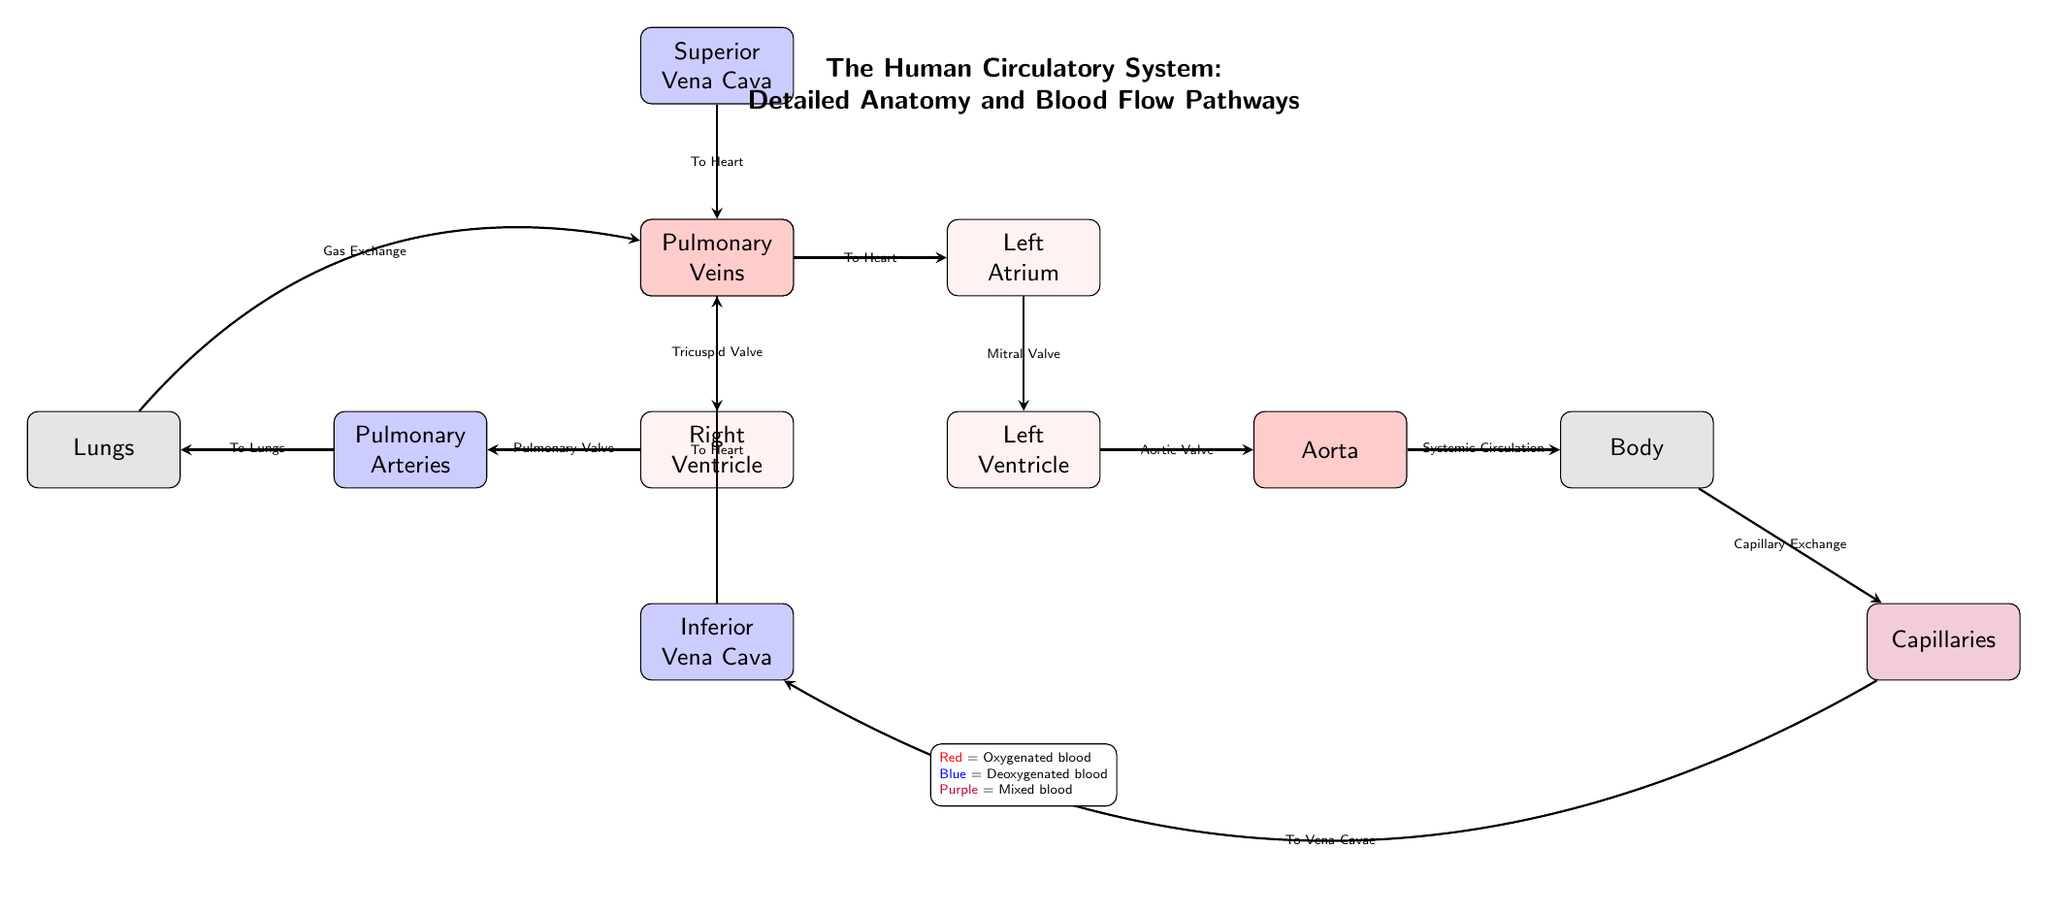What is the color representing oxygenated blood in the diagram? The diagram uses red to represent oxygenated blood, which is indicated in the legend stating that red equals oxygenated blood.
Answer: Red How many heart chambers are shown in the diagram? The diagram displays four heart chambers: the right atrium, right ventricle, left atrium, and left ventricle, which can be counted directly from the labeled nodes.
Answer: Four What valve leads from the right atrium to the right ventricle? The diagram indicates that the valve leading from the right atrium to the right ventricle is the tricuspid valve, as labeled on the corresponding edge in the diagram.
Answer: Tricuspid Valve What is the pathway taken by deoxygenated blood after it leaves the right ventricle? Deoxygenated blood exits the right ventricle through the pulmonary valve and flows into the pulmonary arteries, from where it travels to the lungs for gas exchange; this sequence is traced through the diagram.
Answer: Pulmonary Arteries Where does oxygenated blood flow after passing through the left ventricle? Once oxygenated blood passes through the left ventricle, it flows into the aorta, as indicated by the labeled connection from the left ventricle to the aorta in the diagram.
Answer: Aorta What is the final destination of blood that has completed gas exchange in the body? Blood that has undergone gas exchange in the body ends up at the capillaries, before being directed back towards the inferior vena cava, as depicted in the flow sequence of the diagram.
Answer: Capillaries Which blood vessels bring deoxygenated blood to the heart? The superior vena cava and inferior vena cava are responsible for carrying deoxygenated blood back to the heart, as seen in the initial nodes connected to the right atrium.
Answer: Superior and Inferior Vena Cavae How does blood travel from the lungs back to the heart? Blood travels from the lungs back to the heart via the pulmonary veins, as illustrated by the path connecting the lungs to the left atrium in the diagram.
Answer: Pulmonary Veins 